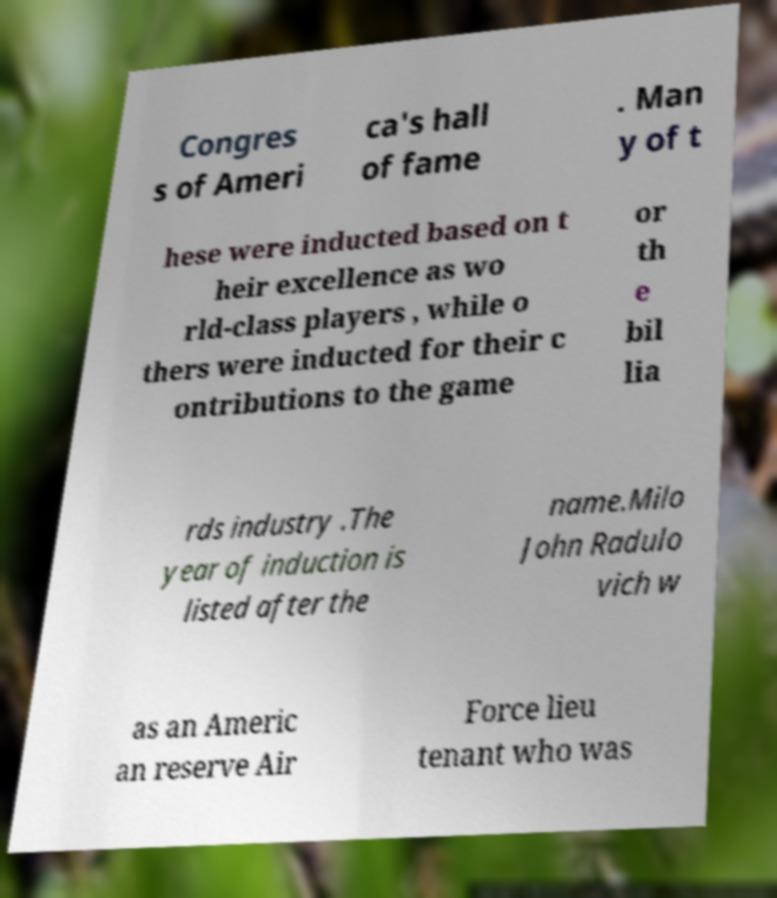For documentation purposes, I need the text within this image transcribed. Could you provide that? Congres s of Ameri ca's hall of fame . Man y of t hese were inducted based on t heir excellence as wo rld-class players , while o thers were inducted for their c ontributions to the game or th e bil lia rds industry .The year of induction is listed after the name.Milo John Radulo vich w as an Americ an reserve Air Force lieu tenant who was 